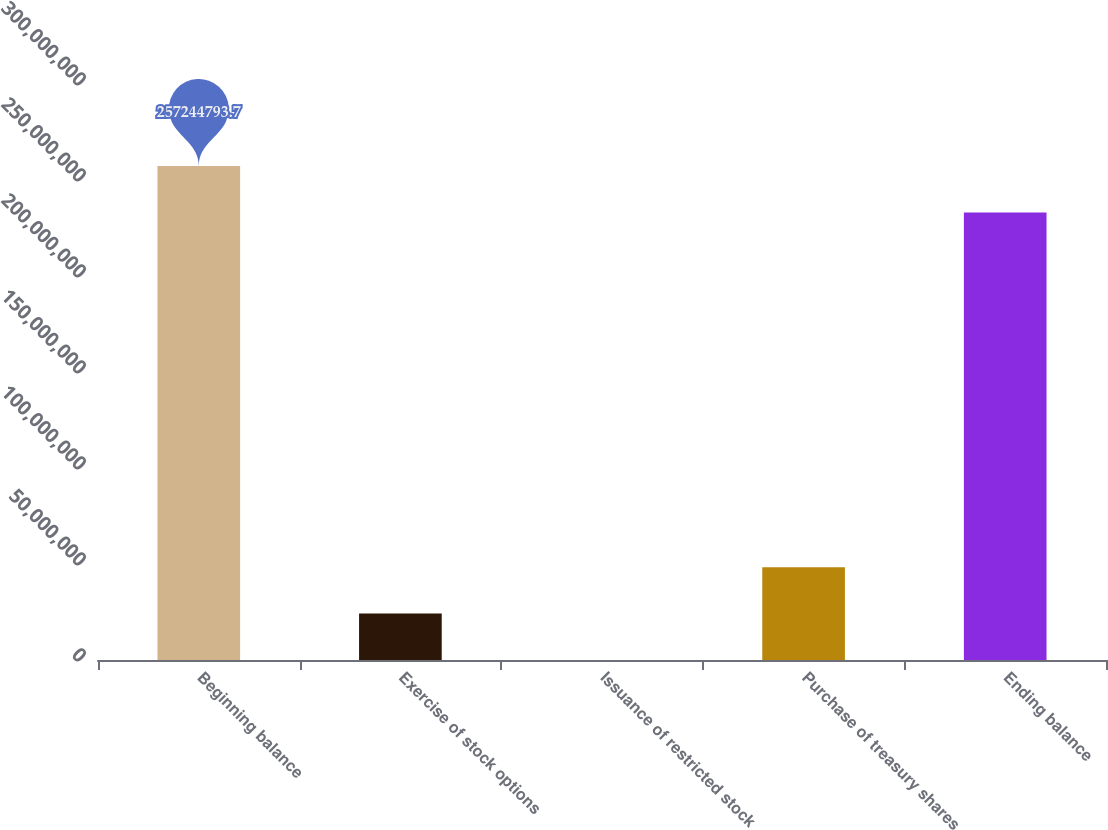Convert chart. <chart><loc_0><loc_0><loc_500><loc_500><bar_chart><fcel>Beginning balance<fcel>Exercise of stock options<fcel>Issuance of restricted stock<fcel>Purchase of treasury shares<fcel>Ending balance<nl><fcel>2.57245e+08<fcel>2.42039e+07<fcel>40673<fcel>4.83671e+07<fcel>2.33082e+08<nl></chart> 